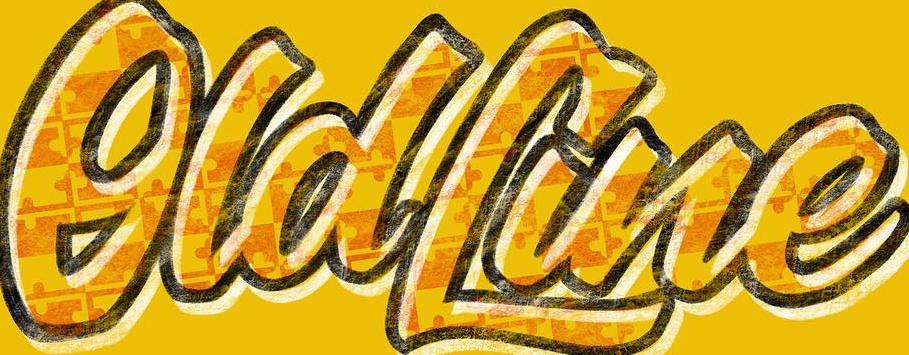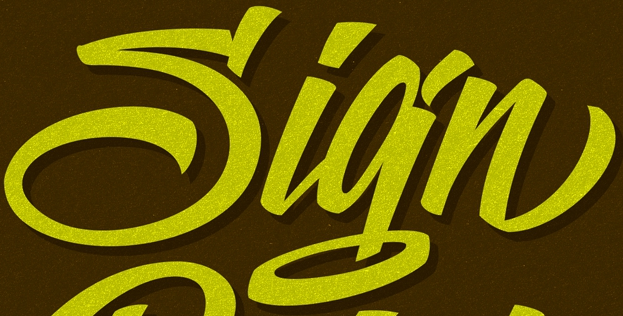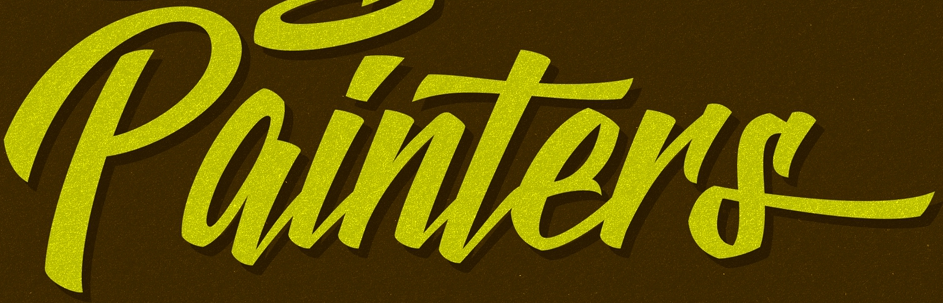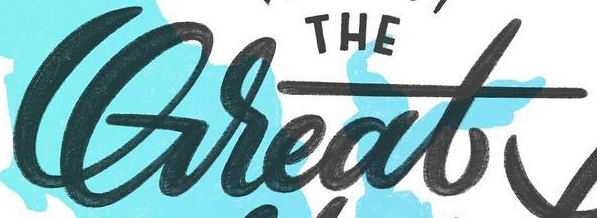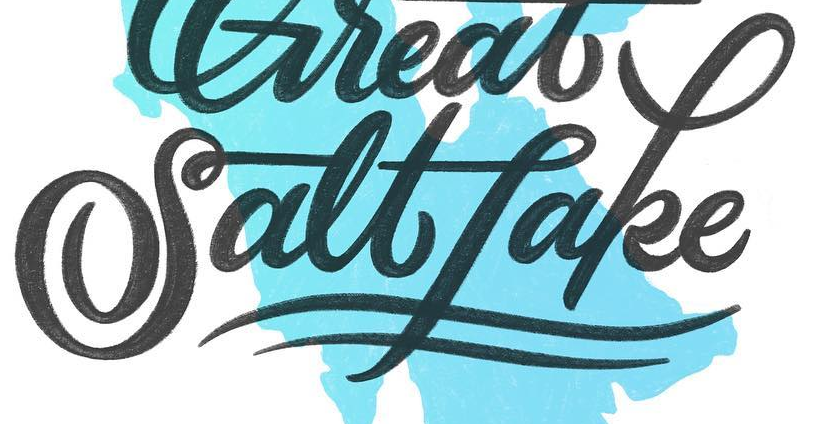Read the text from these images in sequence, separated by a semicolon. OldLine; Sign; painTers; Great; Saltfake 